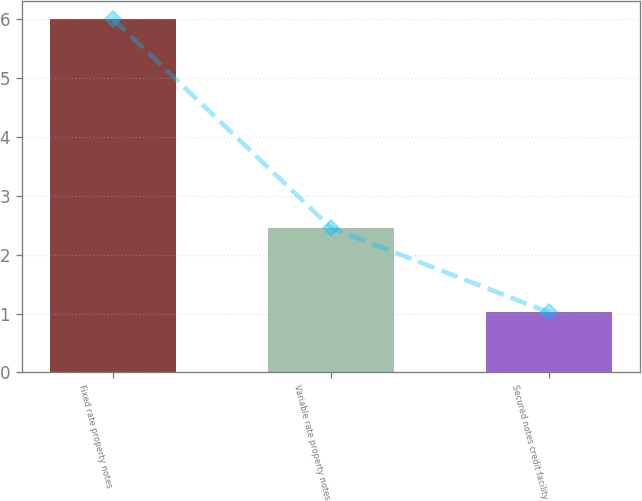Convert chart to OTSL. <chart><loc_0><loc_0><loc_500><loc_500><bar_chart><fcel>Fixed rate property notes<fcel>Variable rate property notes<fcel>Secured notes credit facility<nl><fcel>6.01<fcel>2.46<fcel>1.02<nl></chart> 